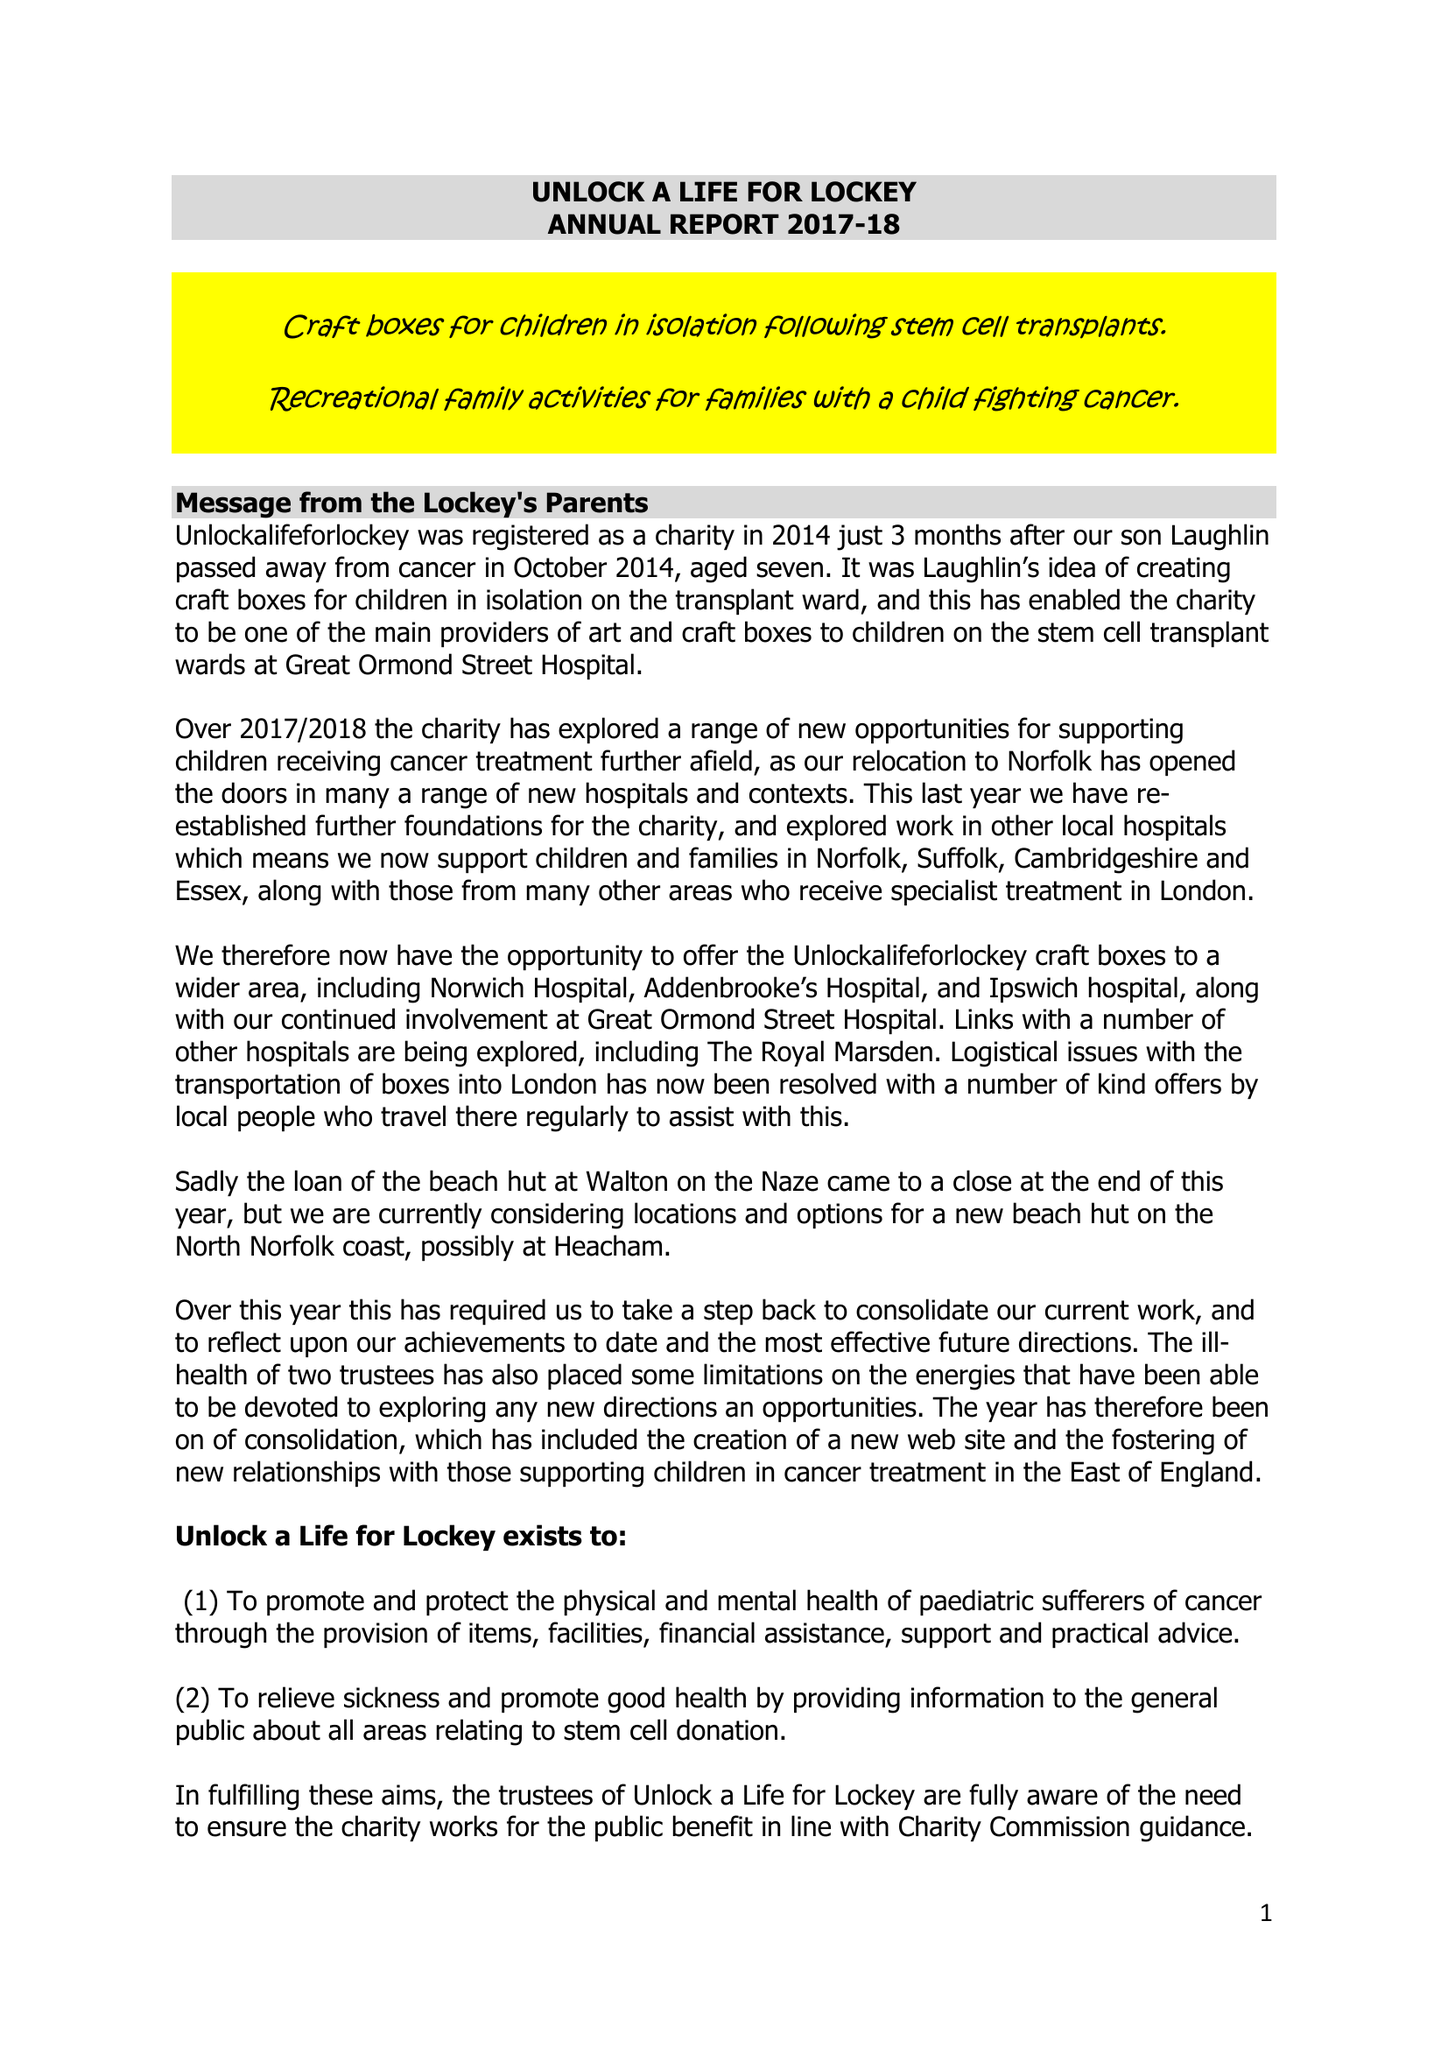What is the value for the address__street_line?
Answer the question using a single word or phrase. STATION ROAD 